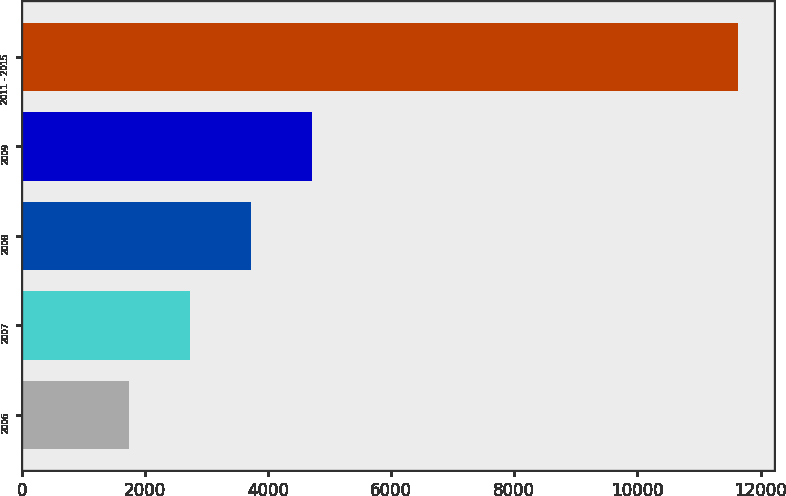Convert chart. <chart><loc_0><loc_0><loc_500><loc_500><bar_chart><fcel>2006<fcel>2007<fcel>2008<fcel>2009<fcel>2011 - 2015<nl><fcel>1750<fcel>2738<fcel>3726<fcel>4714<fcel>11630<nl></chart> 